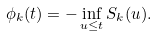<formula> <loc_0><loc_0><loc_500><loc_500>\phi _ { k } ( t ) = - \inf _ { u \leq t } S _ { k } ( u ) .</formula> 